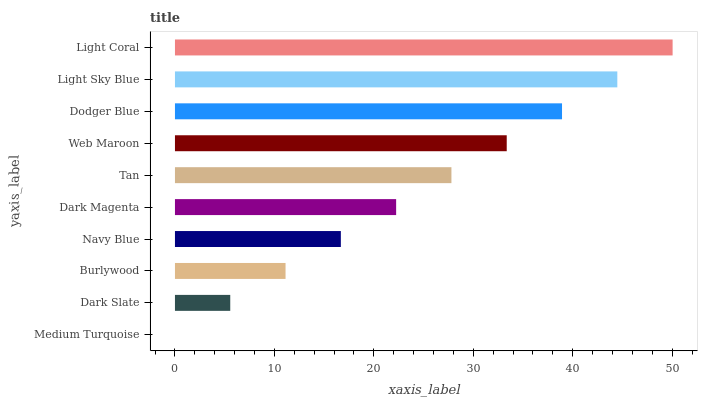Is Medium Turquoise the minimum?
Answer yes or no. Yes. Is Light Coral the maximum?
Answer yes or no. Yes. Is Dark Slate the minimum?
Answer yes or no. No. Is Dark Slate the maximum?
Answer yes or no. No. Is Dark Slate greater than Medium Turquoise?
Answer yes or no. Yes. Is Medium Turquoise less than Dark Slate?
Answer yes or no. Yes. Is Medium Turquoise greater than Dark Slate?
Answer yes or no. No. Is Dark Slate less than Medium Turquoise?
Answer yes or no. No. Is Tan the high median?
Answer yes or no. Yes. Is Dark Magenta the low median?
Answer yes or no. Yes. Is Web Maroon the high median?
Answer yes or no. No. Is Light Coral the low median?
Answer yes or no. No. 